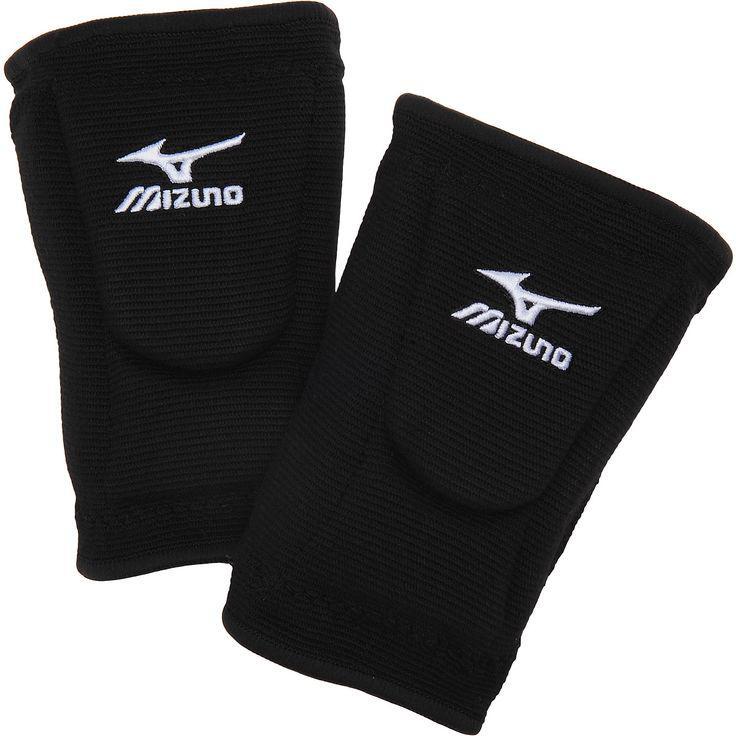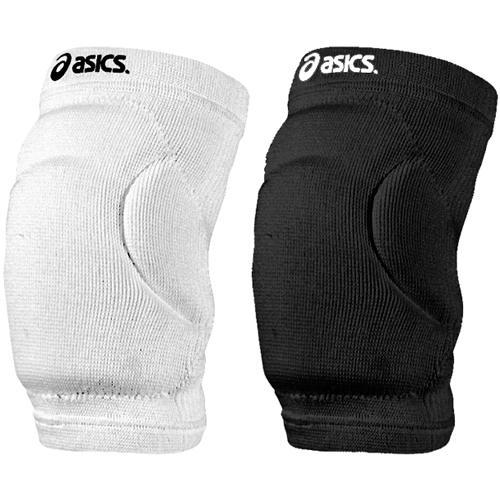The first image is the image on the left, the second image is the image on the right. Analyze the images presented: Is the assertion "One image contains at least three legs wearing different kneepads." valid? Answer yes or no. No. The first image is the image on the left, the second image is the image on the right. Considering the images on both sides, is "The knee braces in the left image are facing towards the left." valid? Answer yes or no. No. 